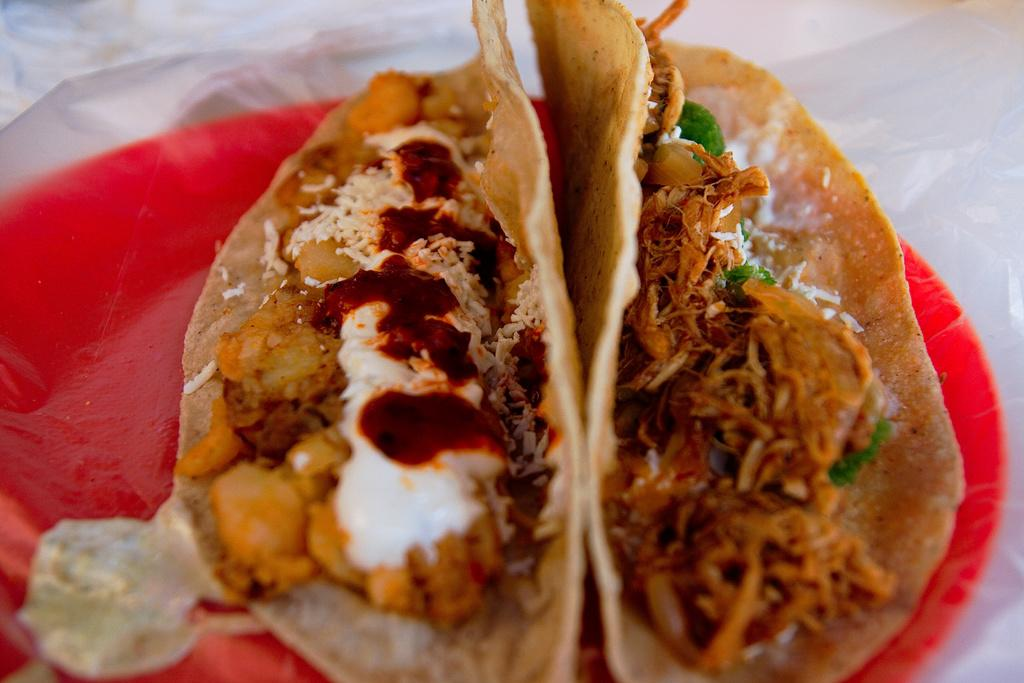What types of establishments are depicted in the image? There are food places in the image. What is the color of the plate on which the food is served? The food places are on a red color plate. What colors can be seen in the food? The food has red, white, and cream colors. What type of thrill can be experienced while eating the food in the image? There is no indication of a thrill associated with the food in the image; it simply shows food places and the colors of the food. 